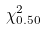Convert formula to latex. <formula><loc_0><loc_0><loc_500><loc_500>\chi _ { 0 . 5 0 } ^ { 2 }</formula> 